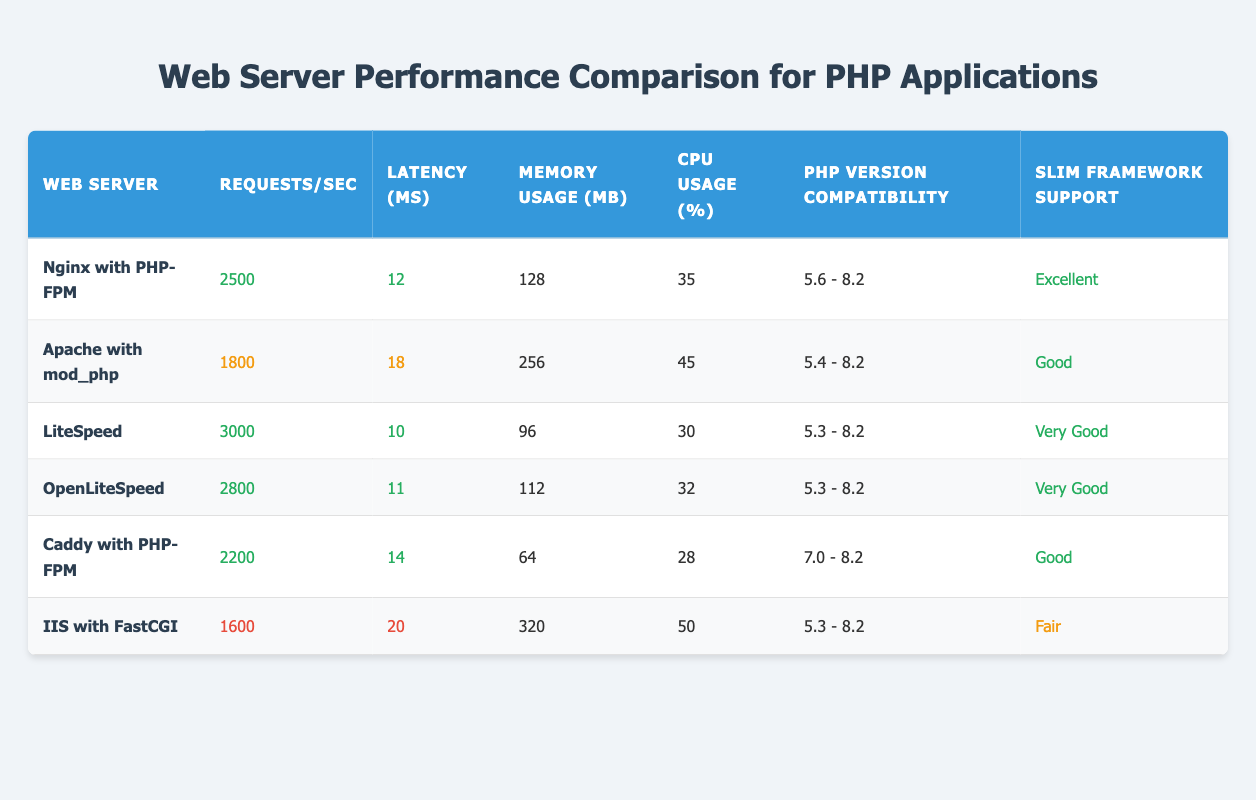What is the highest number of requests per second among the web servers listed? Looking at the "Requests/sec" column, the highest value is in the row for "LiteSpeed," which shows 3000 requests per second. Thus, LiteSpeed has the best performance in this metric.
Answer: 3000 Which web server has the lowest CPU usage? In the "CPU Usage (%)" column, the lowest value is 28%, found in the row for "Caddy with PHP-FPM." This indicates that Caddy has the least CPU usage among the options provided.
Answer: 28 What is the memory usage difference between Apache with mod_php and OpenLiteSpeed? The memory usage for "Apache with mod_php" is 256 MB, while for "OpenLiteSpeed" it is 112 MB. The difference is calculated as 256 MB - 112 MB = 144 MB.
Answer: 144 MB Is Nginx with PHP-FPM compatible with PHP version 5.3? The "PHP Version Compatibility" for "Nginx with PHP-FPM" is listed as "5.6 - 8.2," which does not include PHP version 5.3. Therefore, it is not compatible with that version.
Answer: No Which web server has the best combination of requests per second and latency? Looking at "LiteSpeed," it has the highest requests per second (3000) and the lowest latency (10 ms). No other server matches these high performance metrics simultaneously, making LiteSpeed the best option in this category.
Answer: LiteSpeed What is the average latency of all the web servers listed? To find the average latency, sum the latencies: (12 + 18 + 10 + 11 + 14 + 20) = 85 ms. There are 6 servers, so divide the total by 6, yielding an average latency of 85/6 ≈ 14.17 ms.
Answer: Approximately 14.17 ms How many web servers support "Very Good" Slim Framework support? By examining the "Slim Framework Support" column, we find that both "LiteSpeed" and "OpenLiteSpeed" are categorized as "Very Good." Therefore, the count of web servers with very good support is 2.
Answer: 2 Which web server has the highest latency, and what is that value? Reviewing the "Latency (ms)" column, the highest latency is 20 ms, which belongs to "IIS with FastCGI." This indicates that IIS has the slowest response time among the listed servers.
Answer: 20 ms 